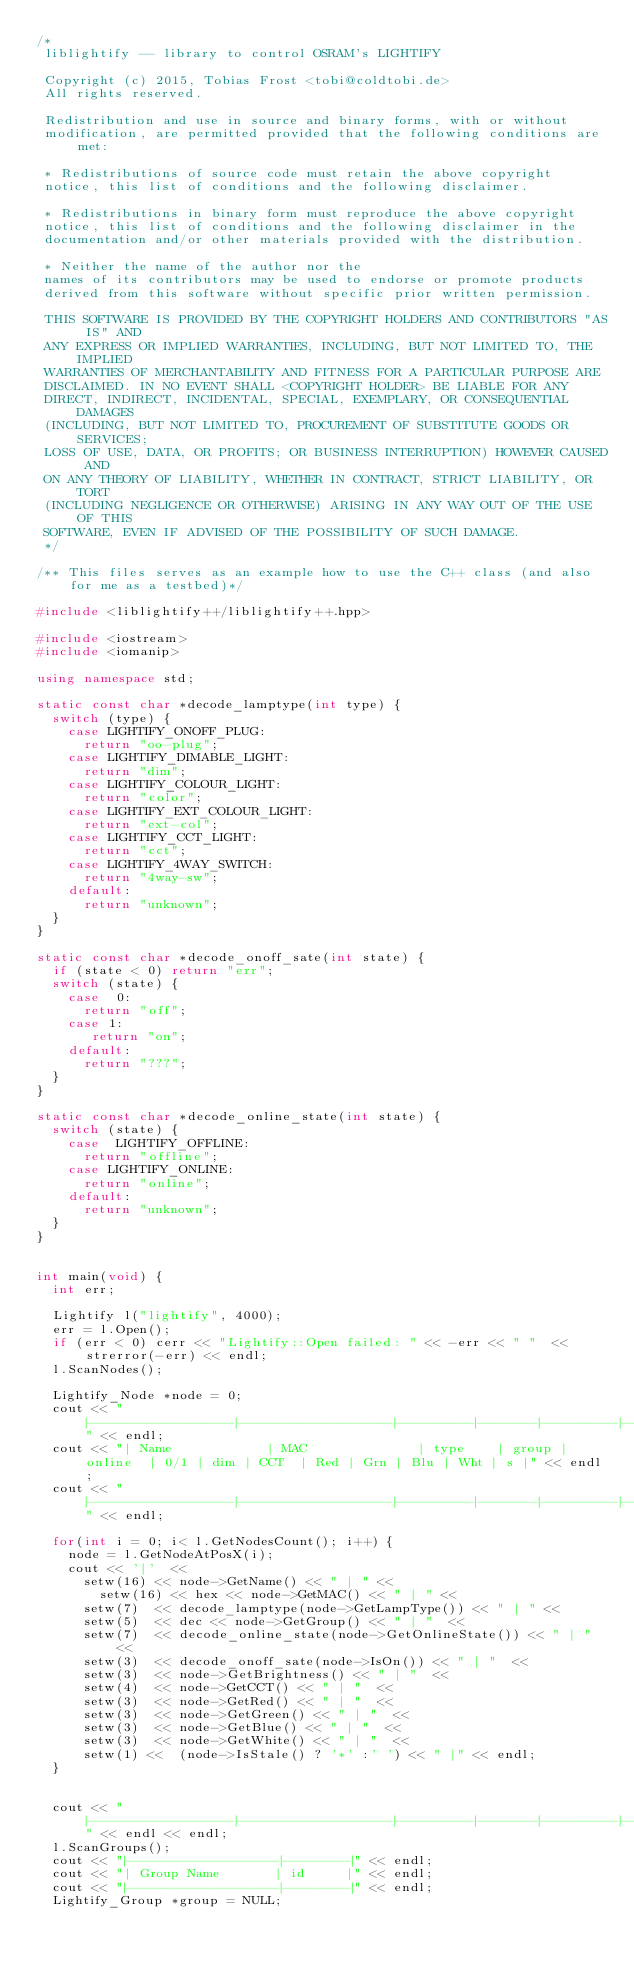Convert code to text. <code><loc_0><loc_0><loc_500><loc_500><_C++_>/*
 liblightify -- library to control OSRAM's LIGHTIFY

 Copyright (c) 2015, Tobias Frost <tobi@coldtobi.de>
 All rights reserved.

 Redistribution and use in source and binary forms, with or without
 modification, are permitted provided that the following conditions are met:

 * Redistributions of source code must retain the above copyright
 notice, this list of conditions and the following disclaimer.

 * Redistributions in binary form must reproduce the above copyright
 notice, this list of conditions and the following disclaimer in the
 documentation and/or other materials provided with the distribution.

 * Neither the name of the author nor the
 names of its contributors may be used to endorse or promote products
 derived from this software without specific prior written permission.

 THIS SOFTWARE IS PROVIDED BY THE COPYRIGHT HOLDERS AND CONTRIBUTORS "AS IS" AND
 ANY EXPRESS OR IMPLIED WARRANTIES, INCLUDING, BUT NOT LIMITED TO, THE IMPLIED
 WARRANTIES OF MERCHANTABILITY AND FITNESS FOR A PARTICULAR PURPOSE ARE
 DISCLAIMED. IN NO EVENT SHALL <COPYRIGHT HOLDER> BE LIABLE FOR ANY
 DIRECT, INDIRECT, INCIDENTAL, SPECIAL, EXEMPLARY, OR CONSEQUENTIAL DAMAGES
 (INCLUDING, BUT NOT LIMITED TO, PROCUREMENT OF SUBSTITUTE GOODS OR SERVICES;
 LOSS OF USE, DATA, OR PROFITS; OR BUSINESS INTERRUPTION) HOWEVER CAUSED AND
 ON ANY THEORY OF LIABILITY, WHETHER IN CONTRACT, STRICT LIABILITY, OR TORT
 (INCLUDING NEGLIGENCE OR OTHERWISE) ARISING IN ANY WAY OUT OF THE USE OF THIS
 SOFTWARE, EVEN IF ADVISED OF THE POSSIBILITY OF SUCH DAMAGE.
 */

/** This files serves as an example how to use the C++ class (and also for me as a testbed)*/

#include <liblightify++/liblightify++.hpp>

#include <iostream>
#include <iomanip>

using namespace std;

static const char *decode_lamptype(int type) {
	switch (type) {
		case LIGHTIFY_ONOFF_PLUG:
			return "oo-plug";
		case LIGHTIFY_DIMABLE_LIGHT:
			return "dim";
		case LIGHTIFY_COLOUR_LIGHT:
			return "color";
		case LIGHTIFY_EXT_COLOUR_LIGHT:
			return "ext-col";
		case LIGHTIFY_CCT_LIGHT:
			return "cct";
		case LIGHTIFY_4WAY_SWITCH:
			return "4way-sw";
		default:
			return "unknown";
	}
}

static const char *decode_onoff_sate(int state) {
	if (state < 0) return "err";
	switch (state) {
		case  0:
			return "off";
		case 1:
			 return "on";
		default:
			return "???";
	}
}

static const char *decode_online_state(int state) {
	switch (state) {
		case  LIGHTIFY_OFFLINE:
			return "offline";
		case LIGHTIFY_ONLINE:
			return "online";
		default:
			return "unknown";
	}
}


int main(void) {
	int err;

	Lightify l("lightify", 4000);
	err = l.Open();
	if (err < 0) cerr << "Lightify::Open failed: " << -err << " "  << strerror(-err) << endl;
	l.ScanNodes();

	Lightify_Node *node = 0;
	cout << "|-----------------|------------------|---------|-------|---------|-----|-----|------|-----|-----|-----|-----|---|" << endl;
	cout << "| Name            | MAC              | type    | group | online  | 0/1 | dim | CCT  | Red | Grn | Blu | Wht | s |" << endl;
	cout << "|-----------------|------------------|---------|-------|---------|-----|-----|------|-----|-----|-----|-----|---|" << endl;

	for(int i = 0; i< l.GetNodesCount(); i++) {
		node = l.GetNodeAtPosX(i);
		cout << '|'  <<
			setw(16) << node->GetName() << " | " <<
		    setw(16) << hex << node->GetMAC() << " | " <<
			setw(7)  << decode_lamptype(node->GetLampType()) << " | " <<
			setw(5)  << dec << node->GetGroup() << " | "  <<
			setw(7)  << decode_online_state(node->GetOnlineState()) << " | " <<
			setw(3)  << decode_onoff_sate(node->IsOn()) << " | "  <<
			setw(3)  << node->GetBrightness() << " | "  <<
			setw(4)  << node->GetCCT() << " | "  <<
			setw(3)  << node->GetRed() << " | "  <<
			setw(3)  << node->GetGreen() << " | "  <<
			setw(3)  << node->GetBlue() << " | "  <<
			setw(3)  << node->GetWhite() << " | "  <<
			setw(1) <<  (node->IsStale() ? '*' :' ') << " |" << endl;
	}


	cout << "|-----------------|------------------|---------|-------|---------|-----|-----|------|-----|-----|-----|-----|---|" << endl << endl;
	l.ScanGroups();
	cout << "|------------------|--------|" << endl;
	cout << "| Group Name       | id     |" << endl;
	cout << "|------------------|--------|" << endl;
	Lightify_Group *group = NULL;</code> 